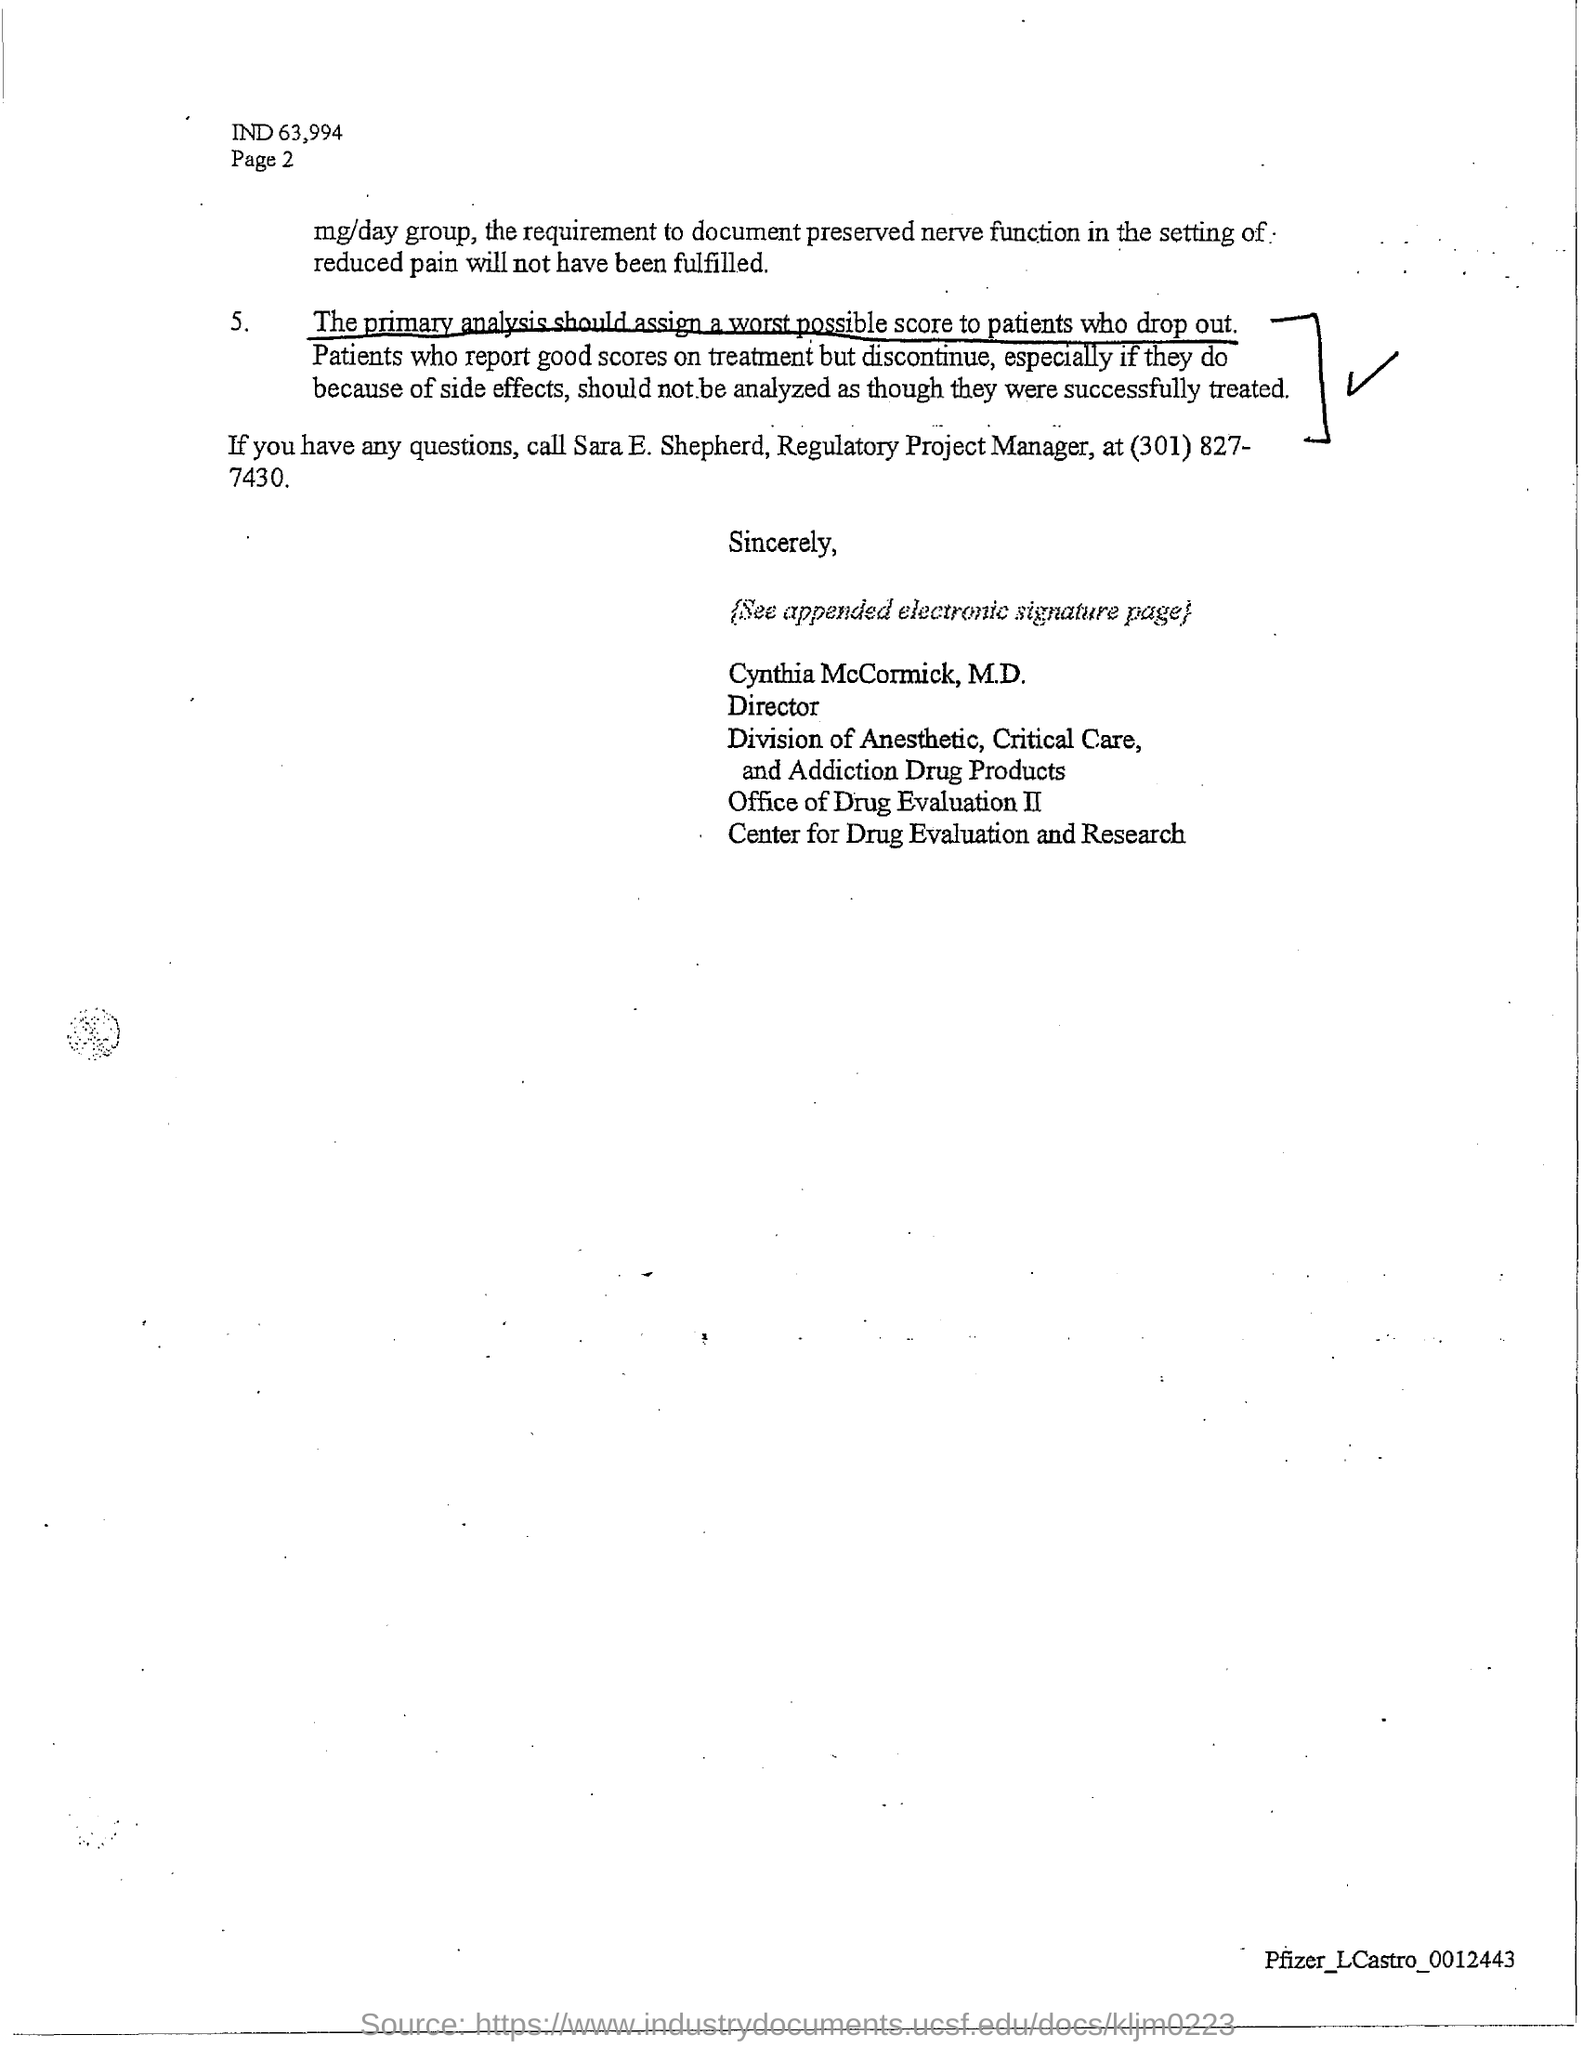What is the designation of Sara E. Shepherd?
Give a very brief answer. REGULATORY PROJECT MANAGER. 